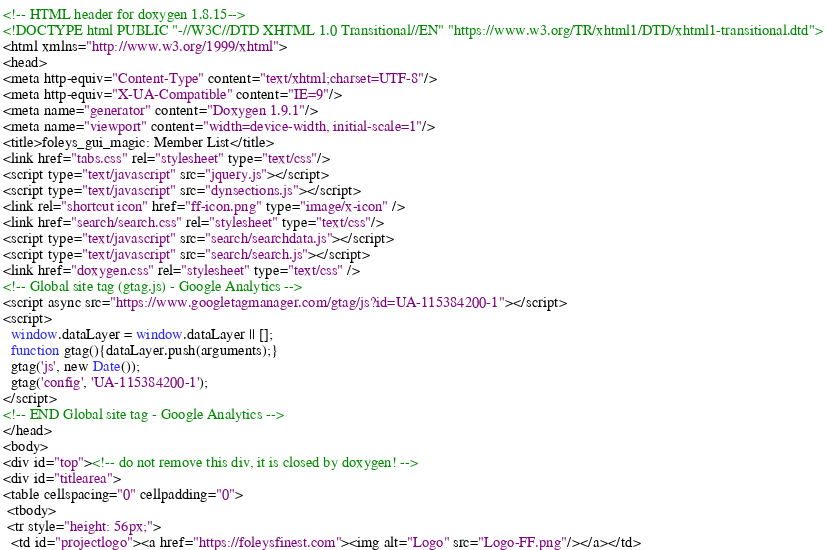Convert code to text. <code><loc_0><loc_0><loc_500><loc_500><_HTML_><!-- HTML header for doxygen 1.8.15-->
<!DOCTYPE html PUBLIC "-//W3C//DTD XHTML 1.0 Transitional//EN" "https://www.w3.org/TR/xhtml1/DTD/xhtml1-transitional.dtd">
<html xmlns="http://www.w3.org/1999/xhtml">
<head>
<meta http-equiv="Content-Type" content="text/xhtml;charset=UTF-8"/>
<meta http-equiv="X-UA-Compatible" content="IE=9"/>
<meta name="generator" content="Doxygen 1.9.1"/>
<meta name="viewport" content="width=device-width, initial-scale=1"/>
<title>foleys_gui_magic: Member List</title>
<link href="tabs.css" rel="stylesheet" type="text/css"/>
<script type="text/javascript" src="jquery.js"></script>
<script type="text/javascript" src="dynsections.js"></script>
<link rel="shortcut icon" href="ff-icon.png" type="image/x-icon" />
<link href="search/search.css" rel="stylesheet" type="text/css"/>
<script type="text/javascript" src="search/searchdata.js"></script>
<script type="text/javascript" src="search/search.js"></script>
<link href="doxygen.css" rel="stylesheet" type="text/css" />
<!-- Global site tag (gtag.js) - Google Analytics -->
<script async src="https://www.googletagmanager.com/gtag/js?id=UA-115384200-1"></script>
<script>
  window.dataLayer = window.dataLayer || [];
  function gtag(){dataLayer.push(arguments);}
  gtag('js', new Date());
  gtag('config', 'UA-115384200-1');
</script>
<!-- END Global site tag - Google Analytics -->
</head>
<body>
<div id="top"><!-- do not remove this div, it is closed by doxygen! -->
<div id="titlearea">
<table cellspacing="0" cellpadding="0">
 <tbody>
 <tr style="height: 56px;">
  <td id="projectlogo"><a href="https://foleysfinest.com"><img alt="Logo" src="Logo-FF.png"/></a></td></code> 